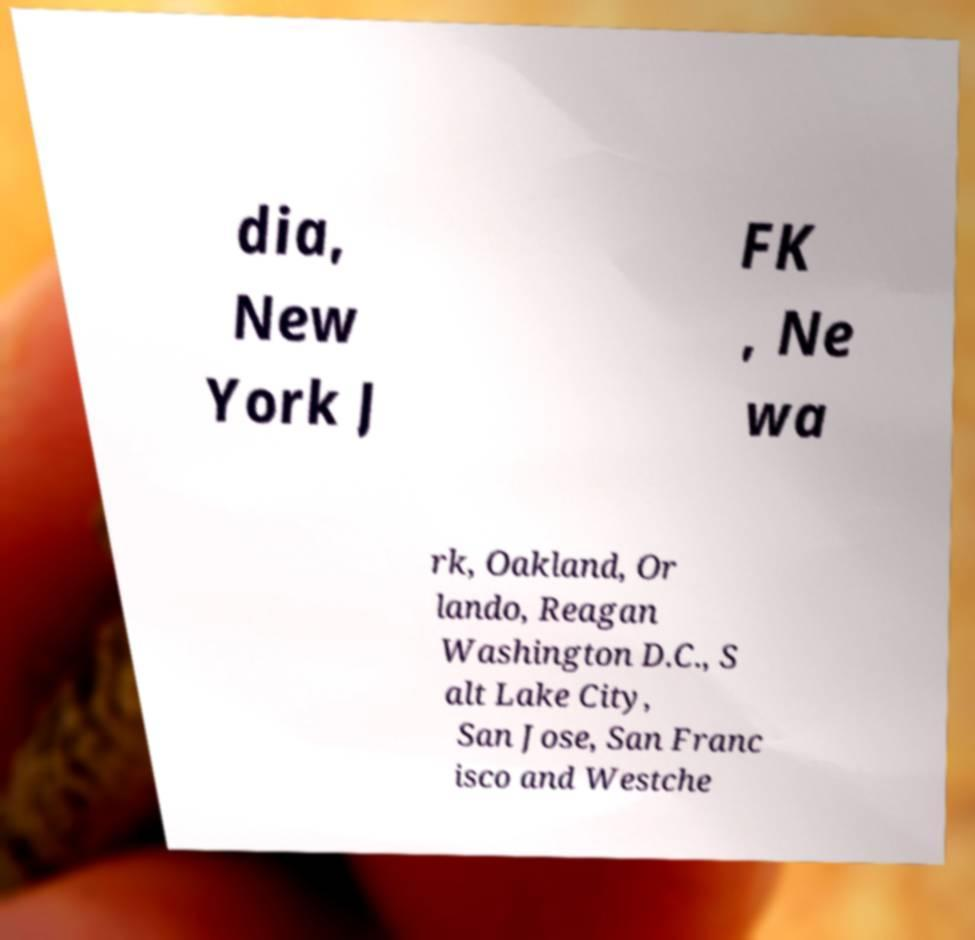Can you accurately transcribe the text from the provided image for me? dia, New York J FK , Ne wa rk, Oakland, Or lando, Reagan Washington D.C., S alt Lake City, San Jose, San Franc isco and Westche 